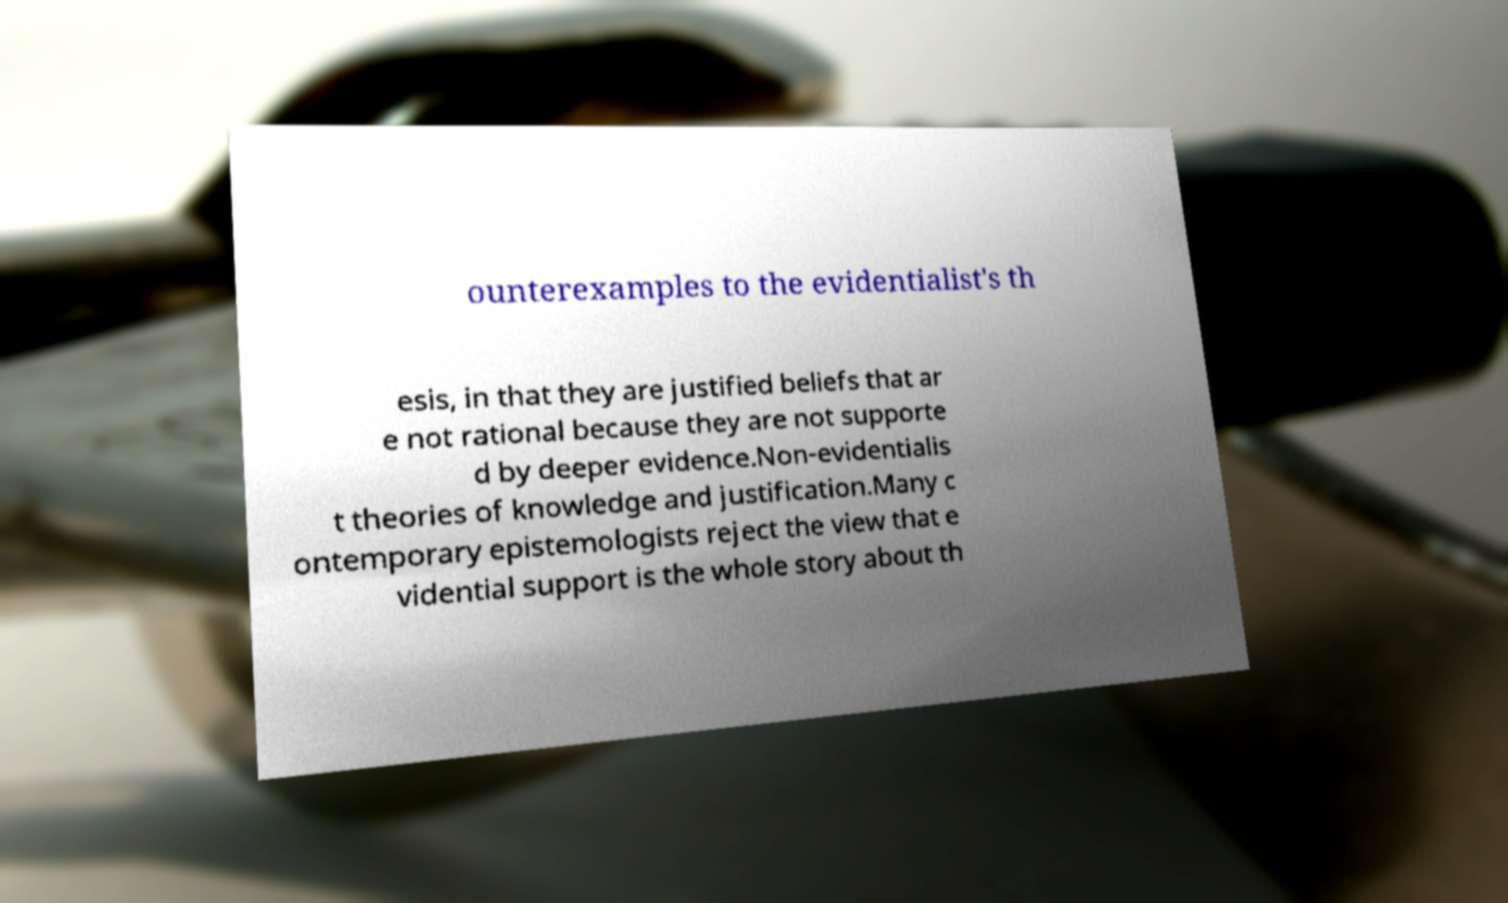For documentation purposes, I need the text within this image transcribed. Could you provide that? ounterexamples to the evidentialist's th esis, in that they are justified beliefs that ar e not rational because they are not supporte d by deeper evidence.Non-evidentialis t theories of knowledge and justification.Many c ontemporary epistemologists reject the view that e vidential support is the whole story about th 